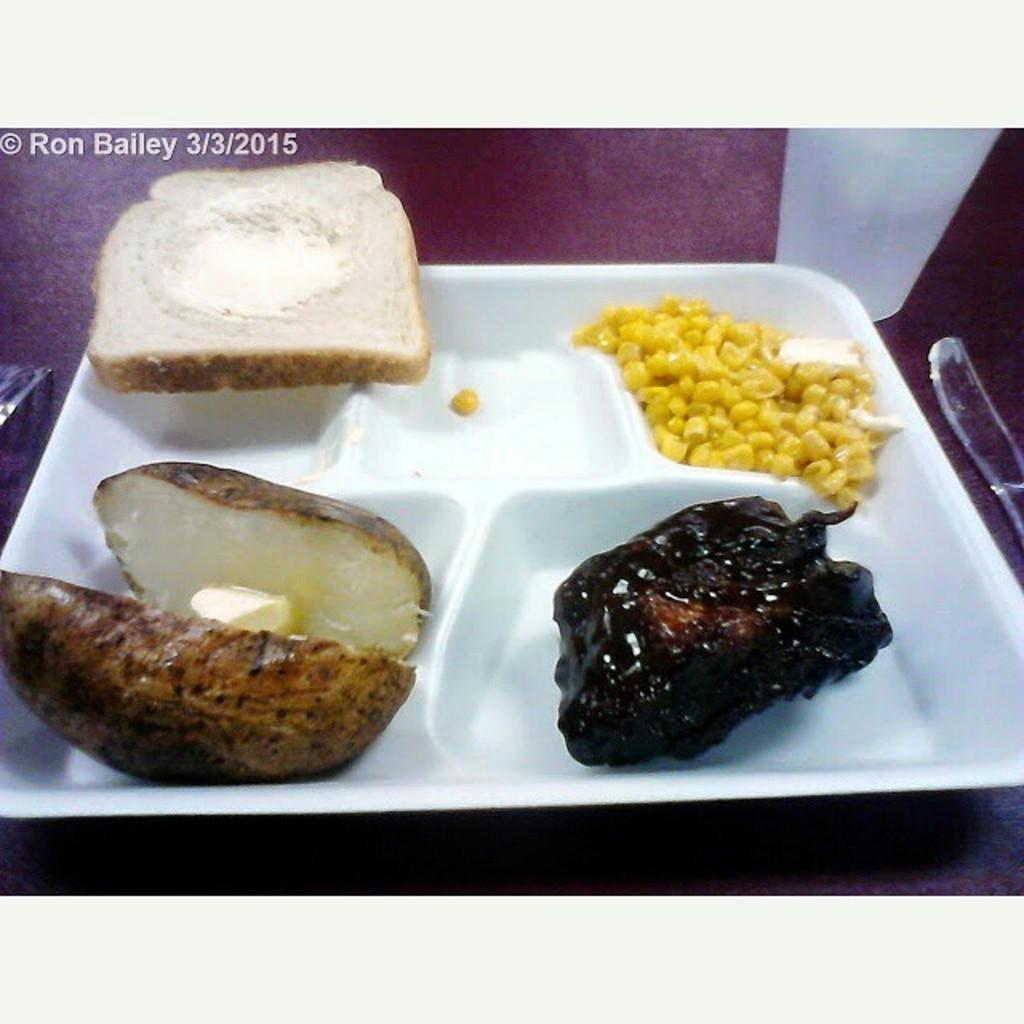What is placed on the white color plate in the image? There are food items on a white color plate in the image. What utensil can be seen in the image? There is a knife on a surface in the image. What other objects are present on the surface in the image? There are other objects on a surface in the image. Can you describe any additional details about the image? There is a watermark in the top left corner of the image. What type of book is placed on the vase in the image? There is no book or vase present in the image. 